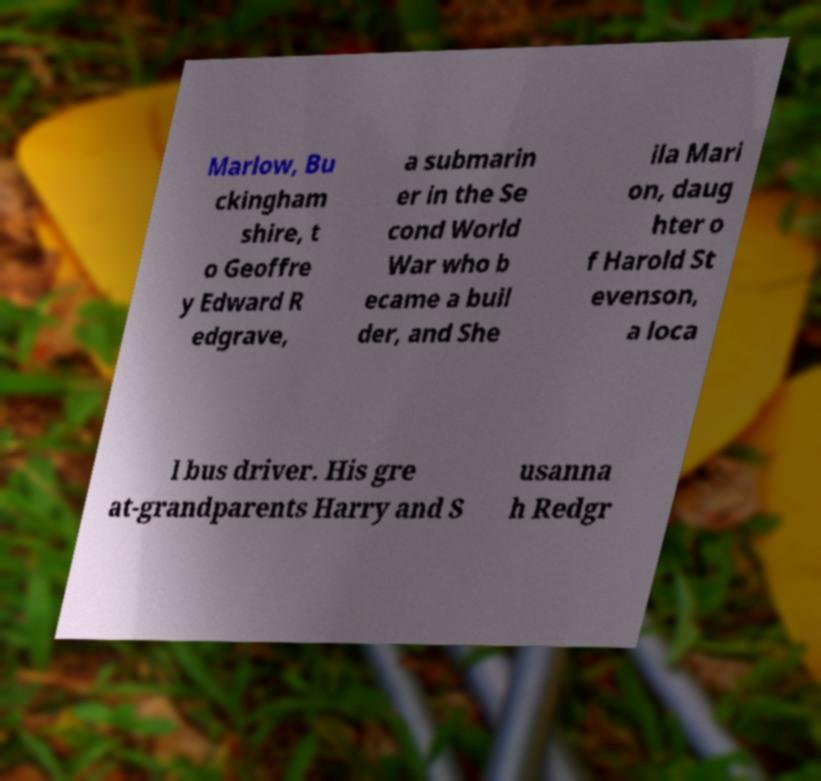Could you assist in decoding the text presented in this image and type it out clearly? Marlow, Bu ckingham shire, t o Geoffre y Edward R edgrave, a submarin er in the Se cond World War who b ecame a buil der, and She ila Mari on, daug hter o f Harold St evenson, a loca l bus driver. His gre at-grandparents Harry and S usanna h Redgr 